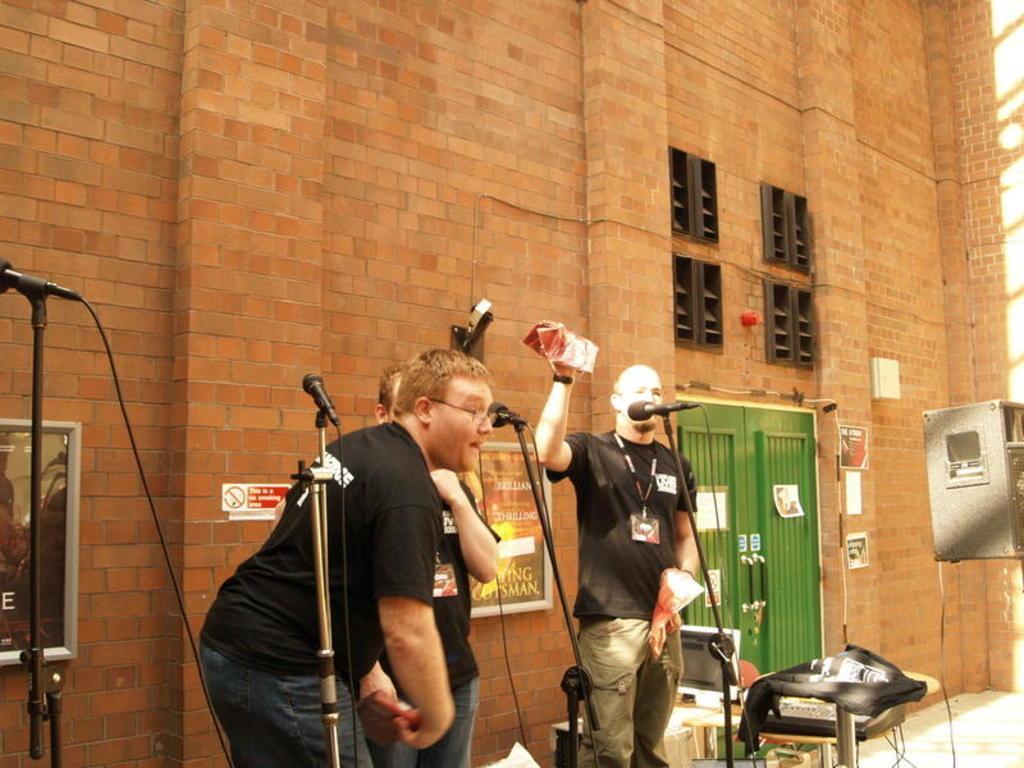Describe this image in one or two sentences. In this image I can see few people are standing and I can see all of them are wearing black t shirt. I can also see two of them are wearing ID cards. Here I can see number of mics, a table, a speaker and in the background I can see few frames on wall, a red colour board and green door. 